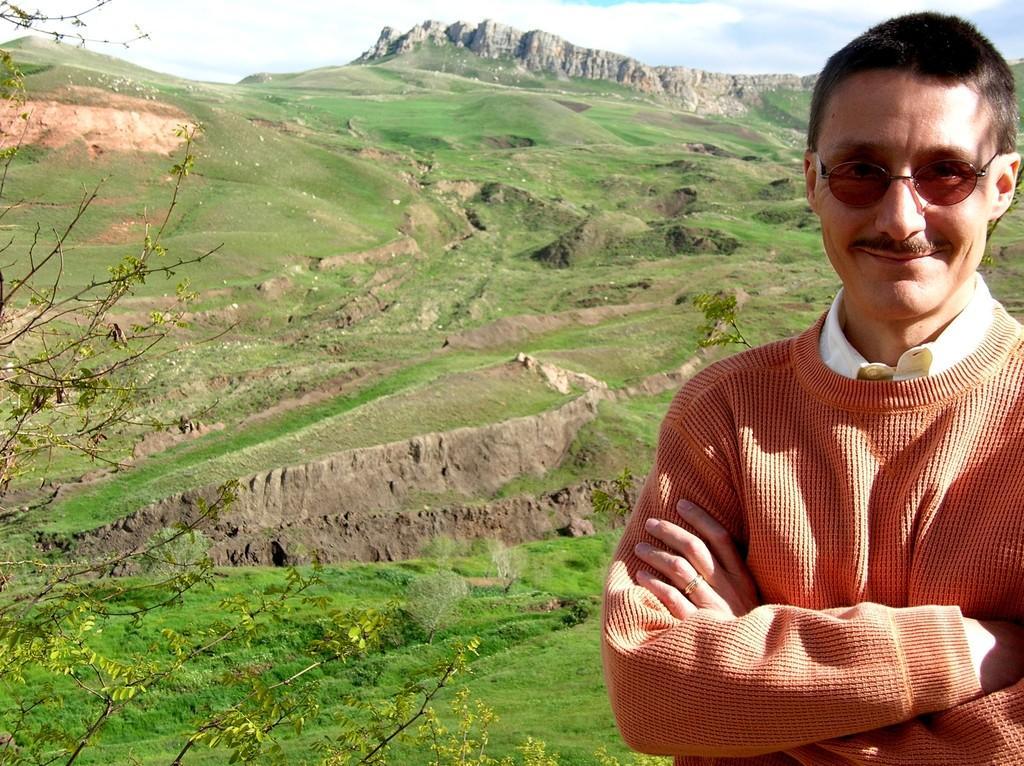Can you describe this image briefly? In this picture I can see a man standing and he wore spectacles and I can see few trees and I can see hill in the back and a blue cloudy sky and I can see grass on the ground. 